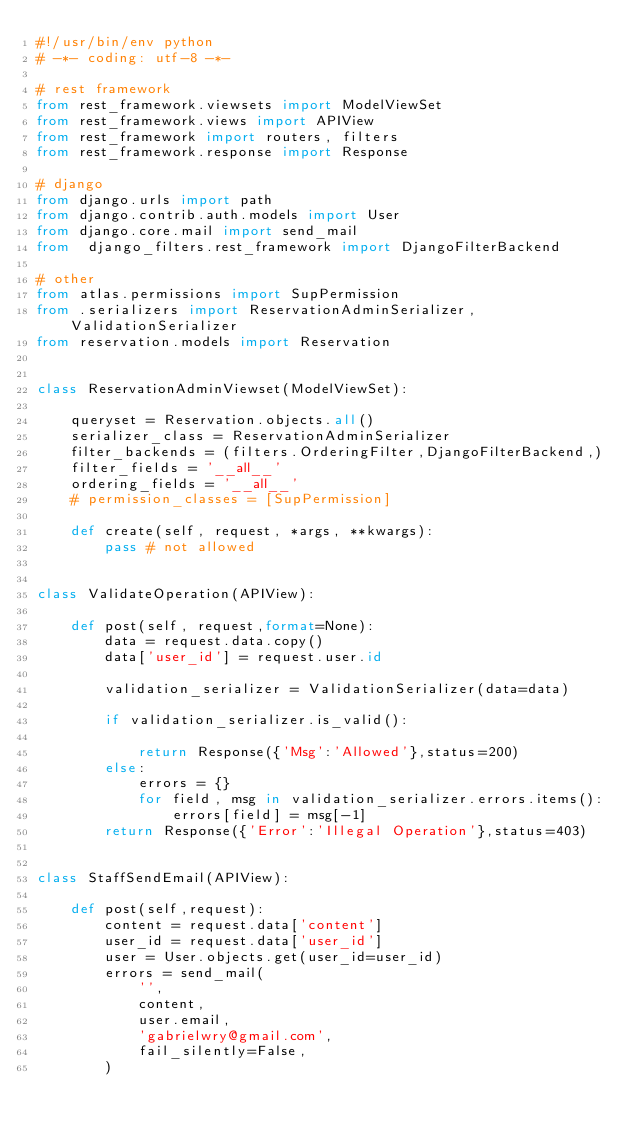<code> <loc_0><loc_0><loc_500><loc_500><_Python_>#!/usr/bin/env python
# -*- coding: utf-8 -*-

# rest framework
from rest_framework.viewsets import ModelViewSet
from rest_framework.views import APIView
from rest_framework import routers, filters
from rest_framework.response import Response

# django
from django.urls import path
from django.contrib.auth.models import User
from django.core.mail import send_mail
from  django_filters.rest_framework import DjangoFilterBackend

# other
from atlas.permissions import SupPermission
from .serializers import ReservationAdminSerializer, ValidationSerializer
from reservation.models import Reservation


class ReservationAdminViewset(ModelViewSet):

    queryset = Reservation.objects.all()
    serializer_class = ReservationAdminSerializer
    filter_backends = (filters.OrderingFilter,DjangoFilterBackend,)
    filter_fields = '__all__'
    ordering_fields = '__all__'
    # permission_classes = [SupPermission]

    def create(self, request, *args, **kwargs):
        pass # not allowed


class ValidateOperation(APIView):

    def post(self, request,format=None):
        data = request.data.copy()
        data['user_id'] = request.user.id

        validation_serializer = ValidationSerializer(data=data)

        if validation_serializer.is_valid():

            return Response({'Msg':'Allowed'},status=200)
        else:
            errors = {}
            for field, msg in validation_serializer.errors.items():
                errors[field] = msg[-1]
        return Response({'Error':'Illegal Operation'},status=403)


class StaffSendEmail(APIView):

    def post(self,request):
        content = request.data['content']
        user_id = request.data['user_id']
        user = User.objects.get(user_id=user_id)
        errors = send_mail(
            '',
            content,
            user.email,
            'gabrielwry@gmail.com',
            fail_silently=False,
        )</code> 